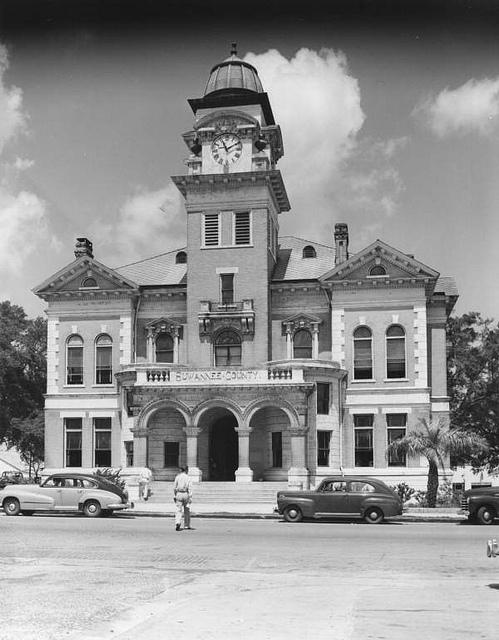Is the sky clear?
Write a very short answer. No. Is the building old?
Short answer required. Yes. Is there grass?
Keep it brief. No. How many staircases lead to the porch?
Answer briefly. 1. How many floors does the building have?
Concise answer only. 3. Was this picture taken recently?
Answer briefly. No. What color is the clock tower?
Keep it brief. White. What might this building be called?
Answer briefly. Church. How many glass panels does the window on the top of the right side of the church have?
Answer briefly. 2. Is the image in black and white?
Short answer required. Yes. Is that a church?
Write a very short answer. Yes. Are there people on the steps?
Keep it brief. No. Is the area in front of the building landscaped?
Short answer required. No. What is this building called?
Answer briefly. Courthouse. 